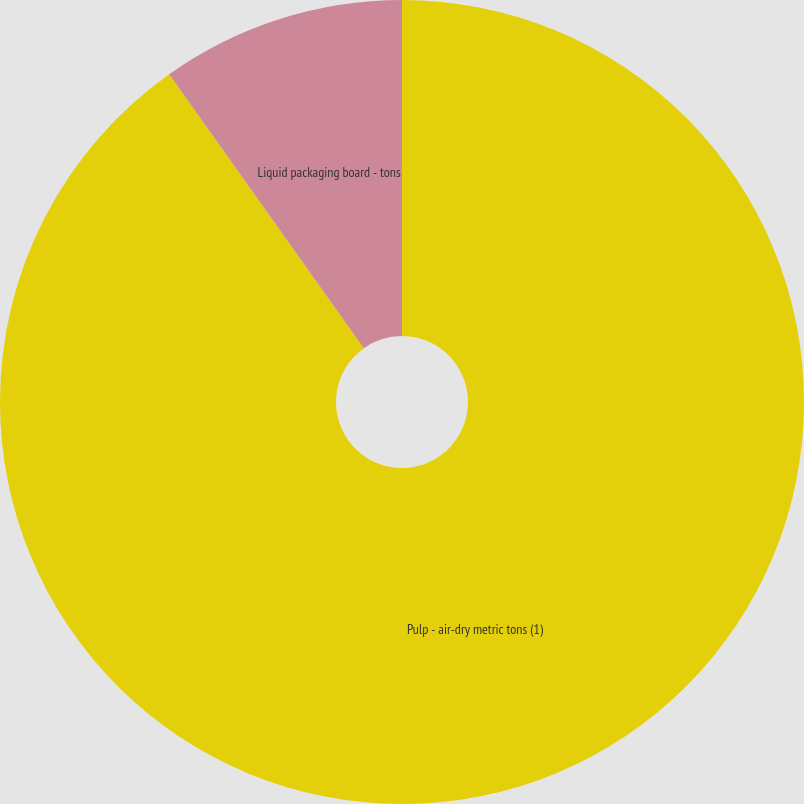Convert chart. <chart><loc_0><loc_0><loc_500><loc_500><pie_chart><fcel>Pulp - air-dry metric tons (1)<fcel>Liquid packaging board - tons<nl><fcel>90.17%<fcel>9.83%<nl></chart> 